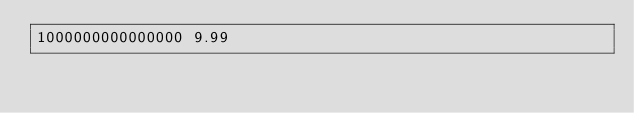Convert code to text. <code><loc_0><loc_0><loc_500><loc_500><_Python_>1000000000000000 9.99</code> 